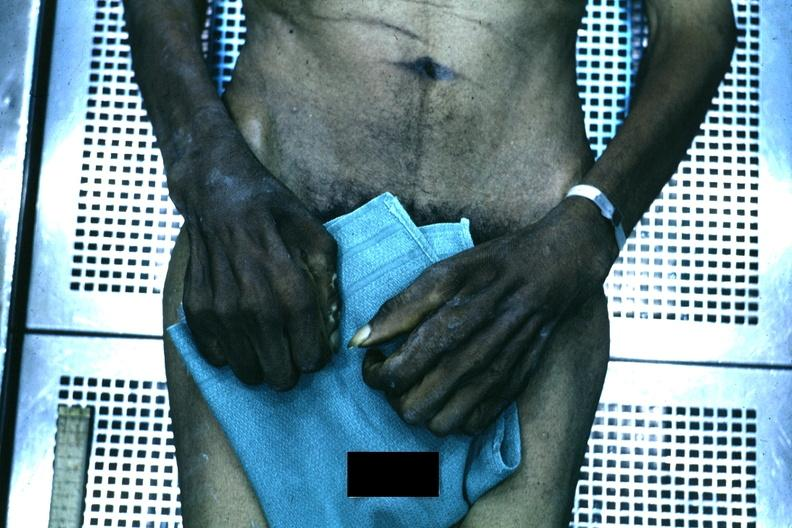re x-ray intramyocardial arteries present?
Answer the question using a single word or phrase. No 